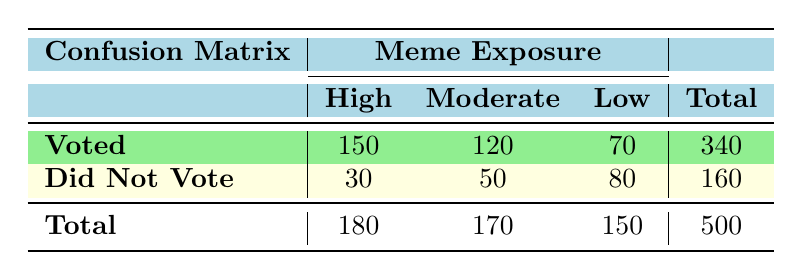What is the total number of youth who voted? The total number of youth who voted is found in the "Voted" row, where the sums for each level of meme exposure (High, Moderate, Low) are 150, 120, and 70, respectively. Adding these values gives us 150 + 120 + 70 = 340.
Answer: 340 How many youth did not vote with high meme exposure? From the confusion matrix, under the "Did Not Vote" row, the count for those with high meme exposure is 30. This value is directly listed in the table.
Answer: 30 What is the total number of youth with low meme exposure? The total number of youth with low meme exposure is the combined total of those who voted and those who did not vote. This can be found by adding the figures in the "Low" column: 70 (Voted) + 80 (Did Not Vote) = 150.
Answer: 150 Did more youth with high meme exposure vote than those with low meme exposure? The number of youth who voted with high meme exposure is 150, while the number of those who voted with low meme exposure is 70. Since 150 is greater than 70, the answer is yes.
Answer: Yes What is the proportion of youth who voted with moderate meme exposure? The total number of youth with moderate meme exposure is found by summing the numbers in that column: 120 (Voted) + 50 (Did Not Vote) = 170. The proportion who voted is then calculated as 120 / 170 = 0.7058 or approximately 70.58%.
Answer: 70.58% What is the average number of youth who voted across all meme exposure levels? To find the average, we need the total number of youth who voted (340) and the total number of exposure categories (3: High, Moderate, Low). So, the average is calculated as 340 / 3 = 113.33.
Answer: 113.33 Is it true that a higher number of youth did not vote across all levels of meme exposure compared to those who did vote? From the table, the total number of youth who did not vote is 160, while those who voted is 340. Since 160 is not greater than 340, the statement is false.
Answer: No What is the difference in the number of youth who voted between high and moderate meme exposure? The numbers of youth who voted are 150 (High) and 120 (Moderate). Subtracting these gives us the difference: 150 - 120 = 30.
Answer: 30 What is the total number of youth who voted and did not vote at low meme exposure? The total number of youth with low meme exposure includes those who voted (70) and those who did not (80). Adding these two figures gives us 70 + 80 = 150.
Answer: 150 